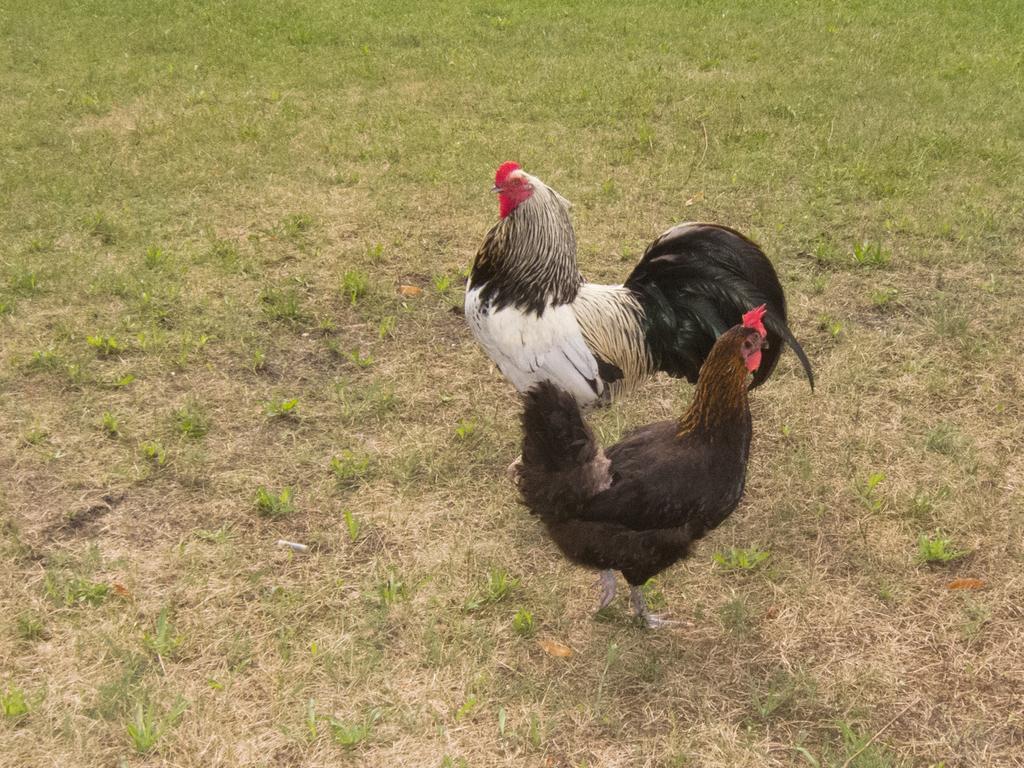Describe this image in one or two sentences. There are two hens standing on a greenery ground. 